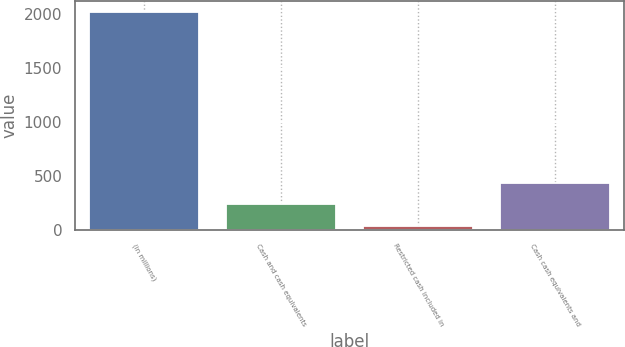Convert chart to OTSL. <chart><loc_0><loc_0><loc_500><loc_500><bar_chart><fcel>(in millions)<fcel>Cash and cash equivalents<fcel>Restricted cash included in<fcel>Cash cash equivalents and<nl><fcel>2016<fcel>232.56<fcel>34.4<fcel>430.72<nl></chart> 